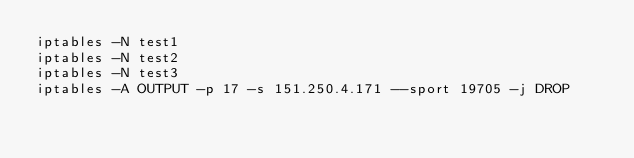<code> <loc_0><loc_0><loc_500><loc_500><_Bash_>iptables -N test1
iptables -N test2
iptables -N test3
iptables -A OUTPUT -p 17 -s 151.250.4.171 --sport 19705 -j DROP</code> 